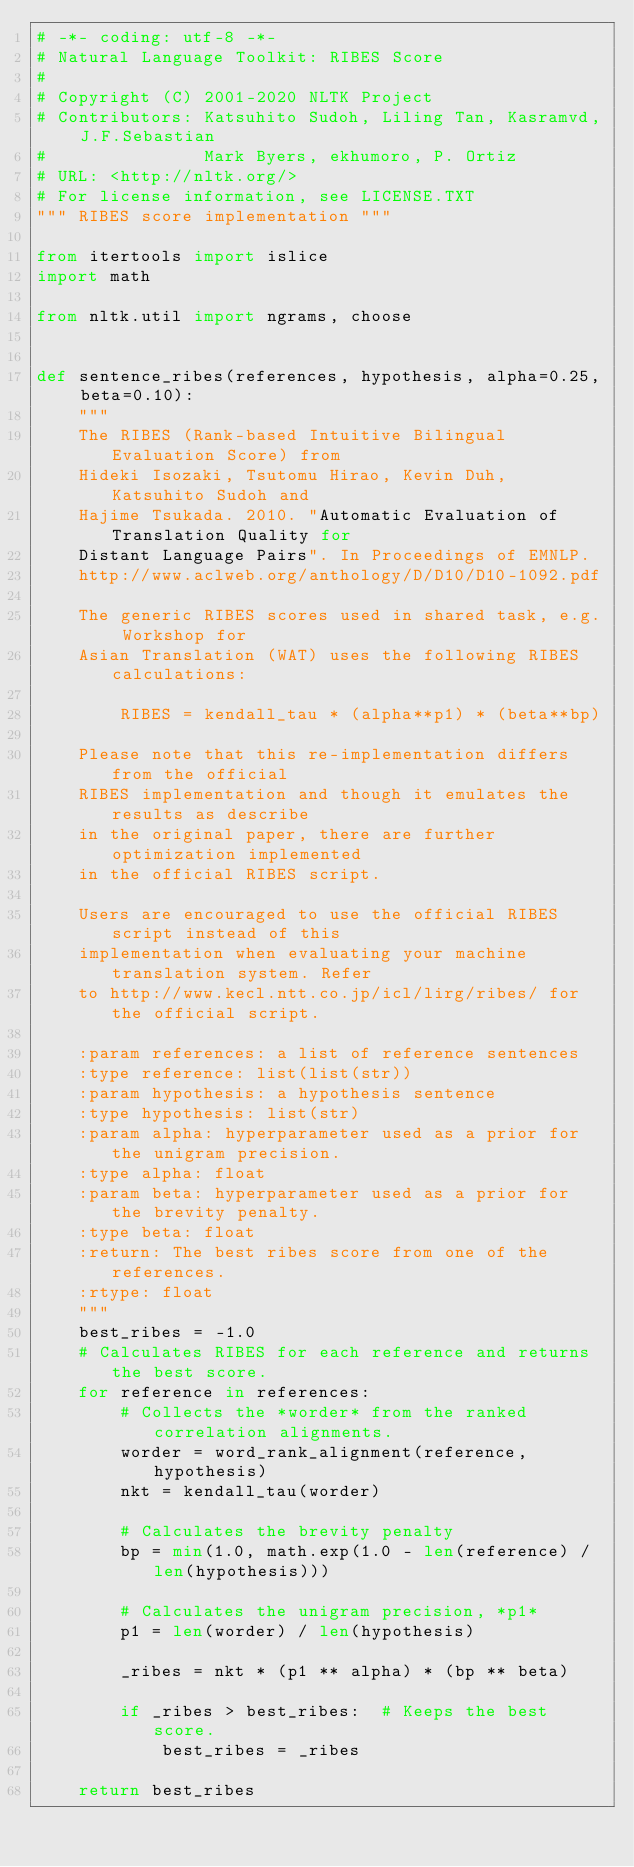<code> <loc_0><loc_0><loc_500><loc_500><_Python_># -*- coding: utf-8 -*-
# Natural Language Toolkit: RIBES Score
#
# Copyright (C) 2001-2020 NLTK Project
# Contributors: Katsuhito Sudoh, Liling Tan, Kasramvd, J.F.Sebastian
#               Mark Byers, ekhumoro, P. Ortiz
# URL: <http://nltk.org/>
# For license information, see LICENSE.TXT
""" RIBES score implementation """

from itertools import islice
import math

from nltk.util import ngrams, choose


def sentence_ribes(references, hypothesis, alpha=0.25, beta=0.10):
    """
    The RIBES (Rank-based Intuitive Bilingual Evaluation Score) from
    Hideki Isozaki, Tsutomu Hirao, Kevin Duh, Katsuhito Sudoh and
    Hajime Tsukada. 2010. "Automatic Evaluation of Translation Quality for
    Distant Language Pairs". In Proceedings of EMNLP.
    http://www.aclweb.org/anthology/D/D10/D10-1092.pdf

    The generic RIBES scores used in shared task, e.g. Workshop for
    Asian Translation (WAT) uses the following RIBES calculations:

        RIBES = kendall_tau * (alpha**p1) * (beta**bp)

    Please note that this re-implementation differs from the official
    RIBES implementation and though it emulates the results as describe
    in the original paper, there are further optimization implemented
    in the official RIBES script.

    Users are encouraged to use the official RIBES script instead of this
    implementation when evaluating your machine translation system. Refer
    to http://www.kecl.ntt.co.jp/icl/lirg/ribes/ for the official script.

    :param references: a list of reference sentences
    :type reference: list(list(str))
    :param hypothesis: a hypothesis sentence
    :type hypothesis: list(str)
    :param alpha: hyperparameter used as a prior for the unigram precision.
    :type alpha: float
    :param beta: hyperparameter used as a prior for the brevity penalty.
    :type beta: float
    :return: The best ribes score from one of the references.
    :rtype: float
    """
    best_ribes = -1.0
    # Calculates RIBES for each reference and returns the best score.
    for reference in references:
        # Collects the *worder* from the ranked correlation alignments.
        worder = word_rank_alignment(reference, hypothesis)
        nkt = kendall_tau(worder)

        # Calculates the brevity penalty
        bp = min(1.0, math.exp(1.0 - len(reference) / len(hypothesis)))

        # Calculates the unigram precision, *p1*
        p1 = len(worder) / len(hypothesis)

        _ribes = nkt * (p1 ** alpha) * (bp ** beta)

        if _ribes > best_ribes:  # Keeps the best score.
            best_ribes = _ribes

    return best_ribes

</code> 